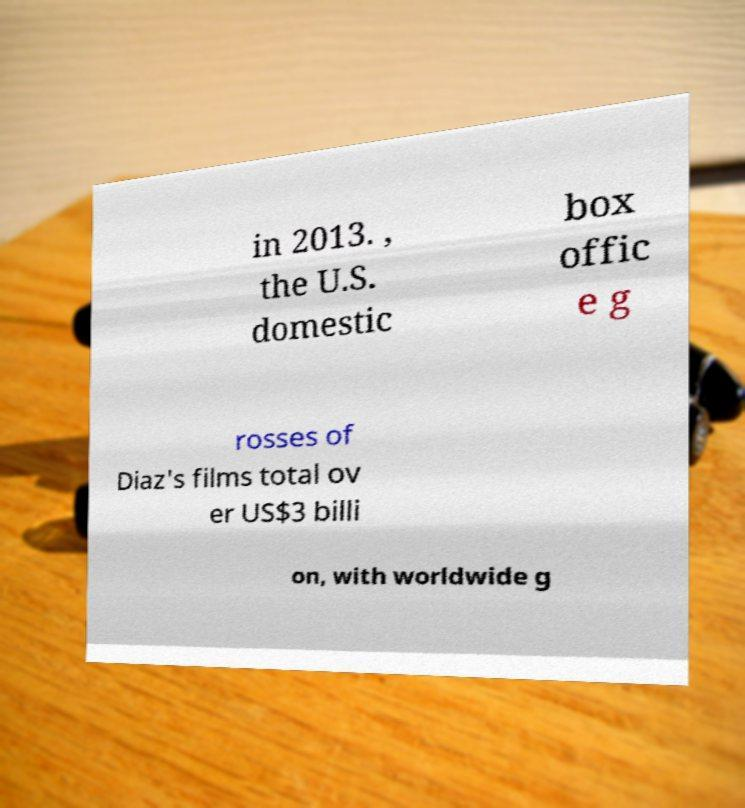There's text embedded in this image that I need extracted. Can you transcribe it verbatim? in 2013. , the U.S. domestic box offic e g rosses of Diaz's films total ov er US$3 billi on, with worldwide g 